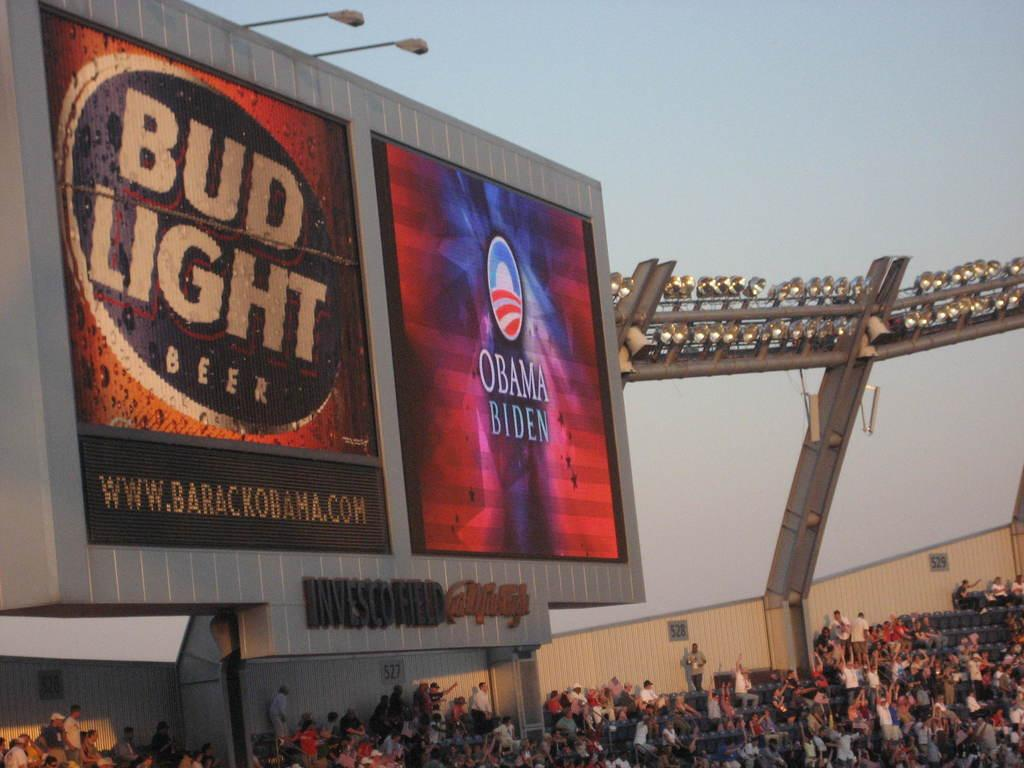<image>
Relay a brief, clear account of the picture shown. A stadium sign that has a bud light and obama/biden advertisement displayed. 